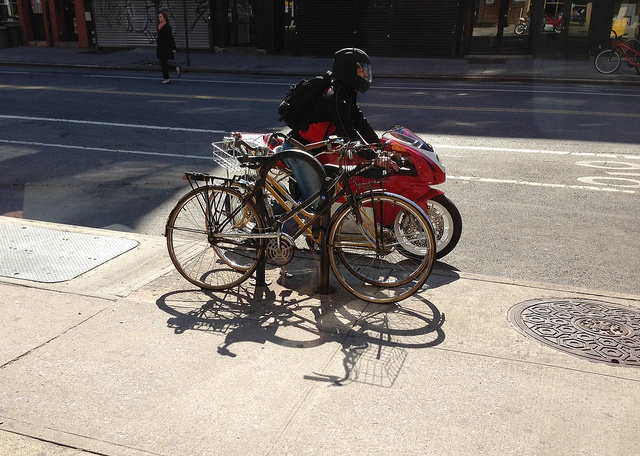Describe the objects in this image and their specific colors. I can see bicycle in black, gray, maroon, and darkgray tones, motorcycle in black, maroon, gray, and darkgray tones, people in black, maroon, and gray tones, bicycle in black, gray, darkgray, and lightgray tones, and backpack in black, gray, and darkgray tones in this image. 